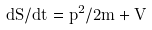Convert formula to latex. <formula><loc_0><loc_0><loc_500><loc_500>d S / d t = p ^ { 2 } / 2 m + V</formula> 